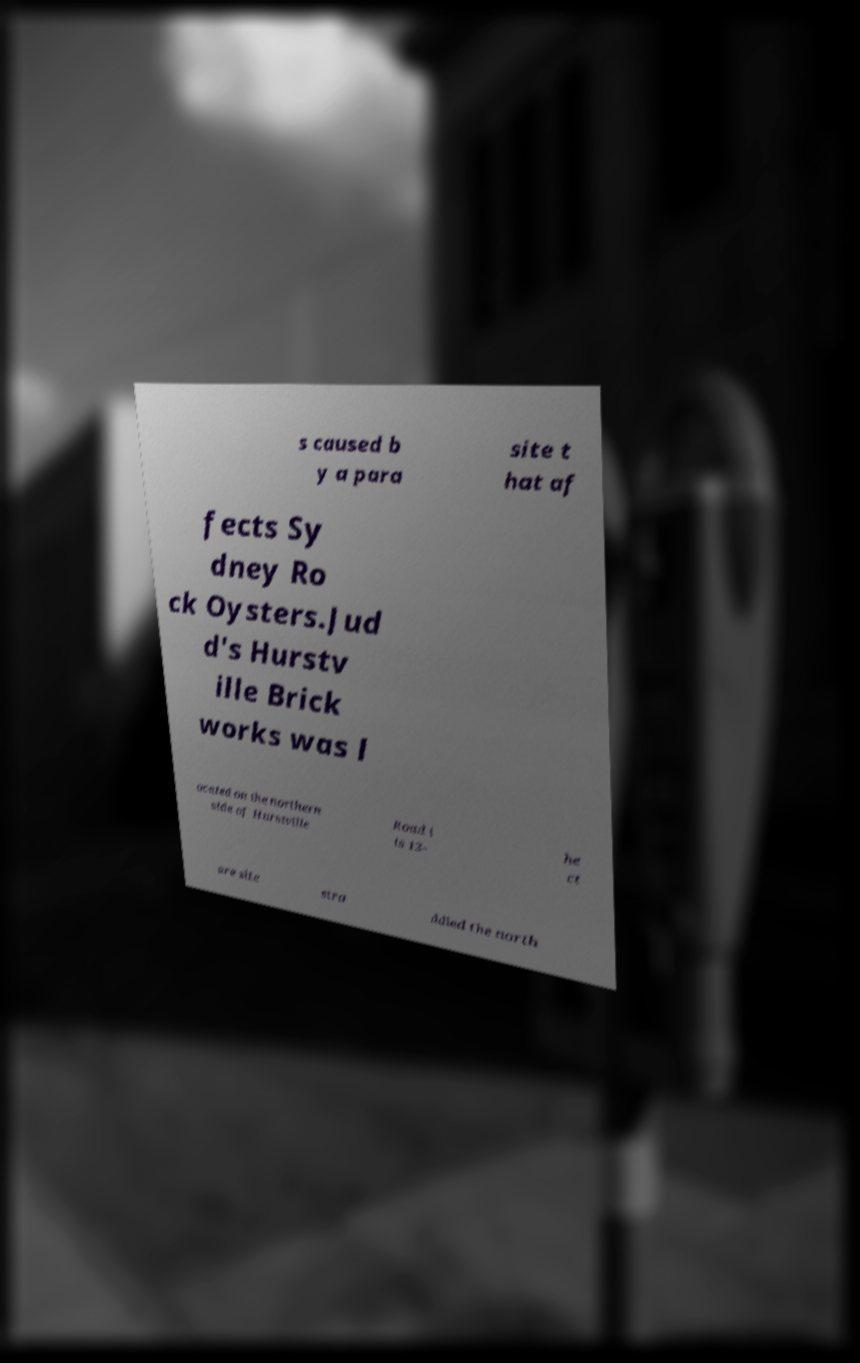Please identify and transcribe the text found in this image. s caused b y a para site t hat af fects Sy dney Ro ck Oysters.Jud d's Hurstv ille Brick works was l ocated on the northern side of Hurstville Road i ts 13- he ct are site stra ddled the north 